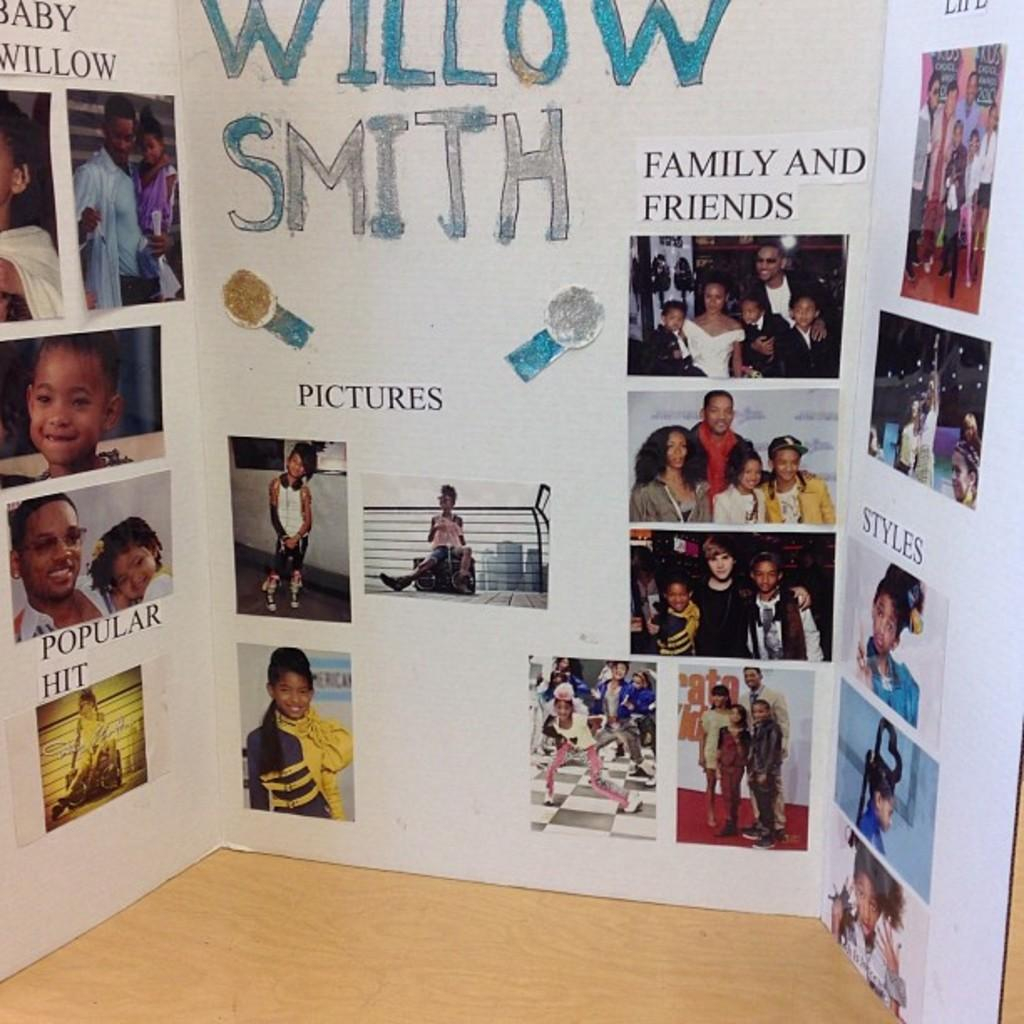What is the main object in the image? There is a board in the image. What can be seen on the board? There are pictures of people on the board, as well as text. What type of floor is visible at the bottom of the image? There is a wooden floor at the bottom of the image. How long is the voyage depicted in the images on the board? There is no voyage depicted in the images on the board; they are pictures of people. What news is being reported on the board? There is no news being reported on the board; it contains pictures of people and text. 